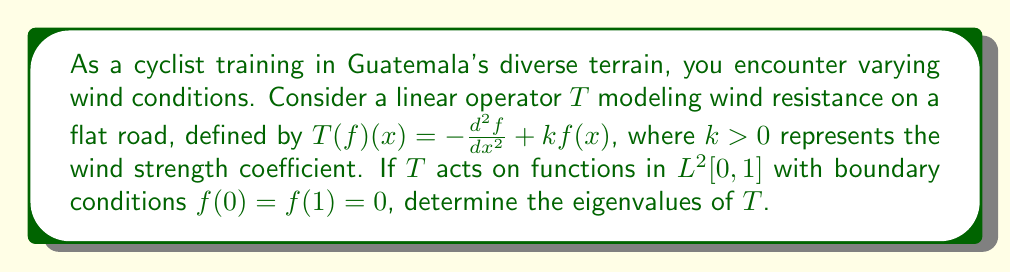Teach me how to tackle this problem. To analyze the spectrum of the linear operator $T$, we follow these steps:

1) The eigenvalue equation for $T$ is:
   $$-\frac{d^2f}{dx^2} + kf(x) = \lambda f(x)$$
   where $\lambda$ represents the eigenvalues.

2) Rearrange the equation:
   $$\frac{d^2f}{dx^2} + (\lambda - k)f(x) = 0$$

3) This is a second-order linear differential equation. Let $\omega^2 = k - \lambda$. The general solution is:
   $$f(x) = A\cos(\omega x) + B\sin(\omega x)$$

4) Apply the boundary conditions:
   $f(0) = 0$ implies $A = 0$
   $f(1) = 0$ implies $B\sin(\omega) = 0$

5) For non-trivial solutions, $\sin(\omega) = 0$, which occurs when $\omega = n\pi$ for $n = 1, 2, 3, ...$

6) Recall that $\omega^2 = k - \lambda$. Therefore:
   $$\lambda_n = k + (n\pi)^2, \quad n = 1, 2, 3, ...$$

7) These are the eigenvalues of the operator $T$.
Answer: $\lambda_n = k + (n\pi)^2$, $n = 1, 2, 3, ...$ 